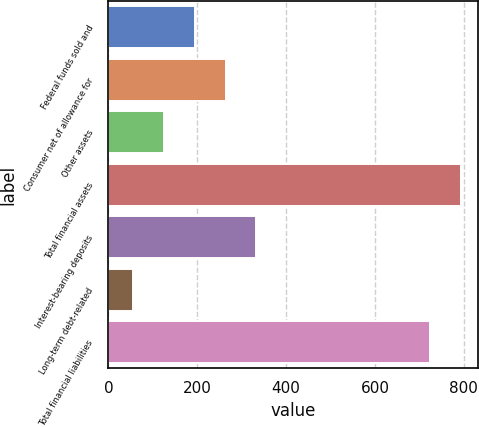<chart> <loc_0><loc_0><loc_500><loc_500><bar_chart><fcel>Federal funds sold and<fcel>Consumer net of allowance for<fcel>Other assets<fcel>Total financial assets<fcel>Interest-bearing deposits<fcel>Long-term debt-related<fcel>Total financial liabilities<nl><fcel>193.98<fcel>263.57<fcel>124.39<fcel>793.19<fcel>333.16<fcel>54.8<fcel>723.6<nl></chart> 